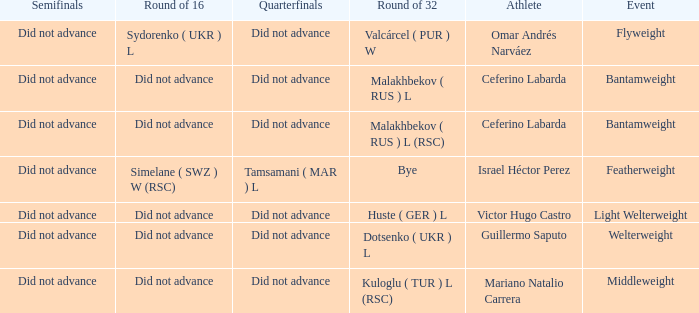Which athlete competed in the flyweight division? Omar Andrés Narváez. 